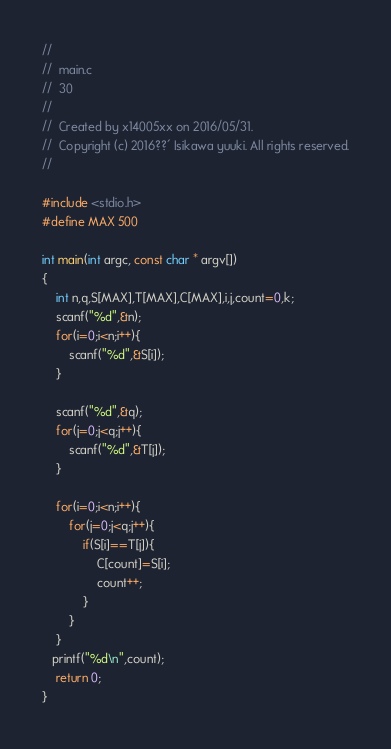<code> <loc_0><loc_0><loc_500><loc_500><_C_>//
//  main.c
//  30
//
//  Created by x14005xx on 2016/05/31.
//  Copyright (c) 2016??´ Isikawa yuuki. All rights reserved.
//

#include <stdio.h>
#define MAX 500

int main(int argc, const char * argv[])
{
    int n,q,S[MAX],T[MAX],C[MAX],i,j,count=0,k;
    scanf("%d",&n);
    for(i=0;i<n;i++){
        scanf("%d",&S[i]);
    }
    
    scanf("%d",&q);
    for(j=0;j<q;j++){
        scanf("%d",&T[j]);
    }
    
    for(i=0;i<n;i++){
        for(j=0;j<q;j++){
            if(S[i]==T[j]){
                C[count]=S[i];
                count++;
            }
        }
    }
   printf("%d\n",count);
    return 0;
}</code> 